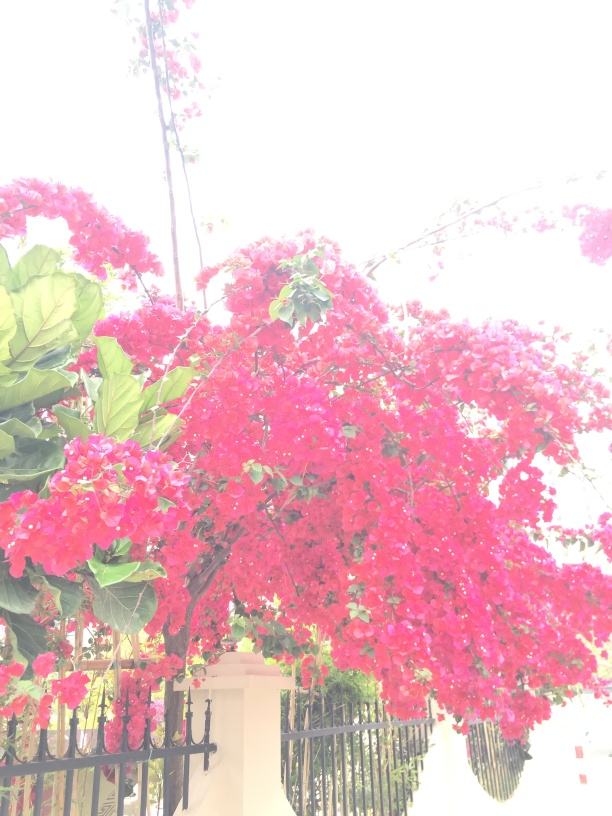What can be improved in this photograph to enhance its visual appeal? To improve the photograph's aesthetic, steps could be taken to reduce the overexposure that washes out the background detail. Techniques such as adjusting exposure levels, using a sunshade or diffuser, or choosing a different time of day to capture the image when lighting is more even could greatly enhance the visual appeal. 